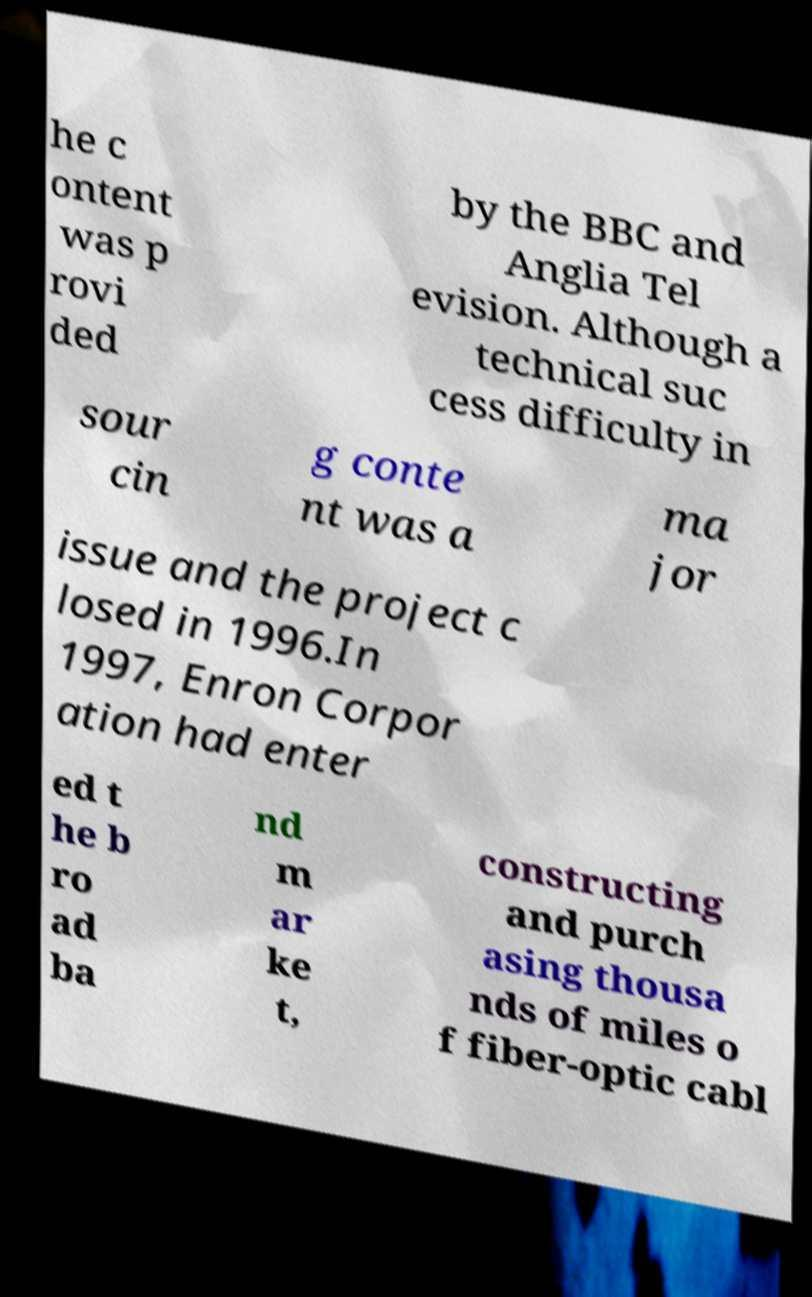Could you assist in decoding the text presented in this image and type it out clearly? he c ontent was p rovi ded by the BBC and Anglia Tel evision. Although a technical suc cess difficulty in sour cin g conte nt was a ma jor issue and the project c losed in 1996.In 1997, Enron Corpor ation had enter ed t he b ro ad ba nd m ar ke t, constructing and purch asing thousa nds of miles o f fiber-optic cabl 